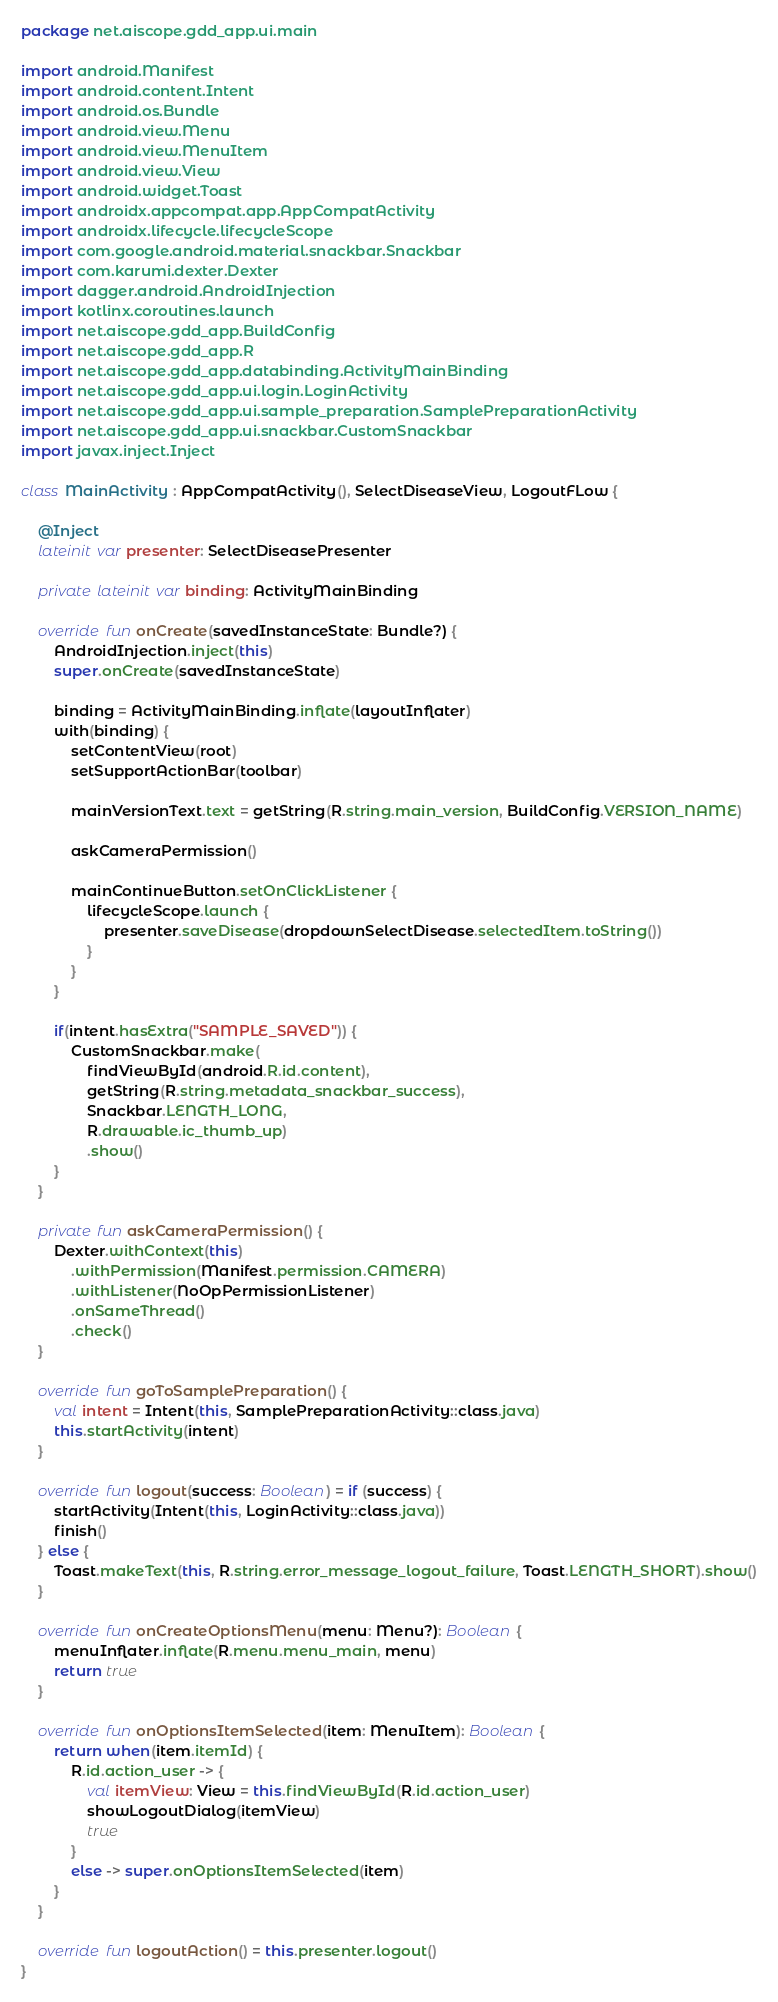<code> <loc_0><loc_0><loc_500><loc_500><_Kotlin_>package net.aiscope.gdd_app.ui.main

import android.Manifest
import android.content.Intent
import android.os.Bundle
import android.view.Menu
import android.view.MenuItem
import android.view.View
import android.widget.Toast
import androidx.appcompat.app.AppCompatActivity
import androidx.lifecycle.lifecycleScope
import com.google.android.material.snackbar.Snackbar
import com.karumi.dexter.Dexter
import dagger.android.AndroidInjection
import kotlinx.coroutines.launch
import net.aiscope.gdd_app.BuildConfig
import net.aiscope.gdd_app.R
import net.aiscope.gdd_app.databinding.ActivityMainBinding
import net.aiscope.gdd_app.ui.login.LoginActivity
import net.aiscope.gdd_app.ui.sample_preparation.SamplePreparationActivity
import net.aiscope.gdd_app.ui.snackbar.CustomSnackbar
import javax.inject.Inject

class MainActivity : AppCompatActivity(), SelectDiseaseView, LogoutFLow {

    @Inject
    lateinit var presenter: SelectDiseasePresenter

    private lateinit var binding: ActivityMainBinding

    override fun onCreate(savedInstanceState: Bundle?) {
        AndroidInjection.inject(this)
        super.onCreate(savedInstanceState)

        binding = ActivityMainBinding.inflate(layoutInflater)
        with(binding) {
            setContentView(root)
            setSupportActionBar(toolbar)

            mainVersionText.text = getString(R.string.main_version, BuildConfig.VERSION_NAME)

            askCameraPermission()

            mainContinueButton.setOnClickListener {
                lifecycleScope.launch {
                    presenter.saveDisease(dropdownSelectDisease.selectedItem.toString())
                }
            }
        }

        if(intent.hasExtra("SAMPLE_SAVED")) {
            CustomSnackbar.make(
                findViewById(android.R.id.content),
                getString(R.string.metadata_snackbar_success),
                Snackbar.LENGTH_LONG,
                R.drawable.ic_thumb_up)
                .show()
        }
    }

    private fun askCameraPermission() {
        Dexter.withContext(this)
            .withPermission(Manifest.permission.CAMERA)
            .withListener(NoOpPermissionListener)
            .onSameThread()
            .check()
    }

    override fun goToSamplePreparation() {
        val intent = Intent(this, SamplePreparationActivity::class.java)
        this.startActivity(intent)
    }

    override fun logout(success: Boolean) = if (success) {
        startActivity(Intent(this, LoginActivity::class.java))
        finish()
    } else {
        Toast.makeText(this, R.string.error_message_logout_failure, Toast.LENGTH_SHORT).show()
    }

    override fun onCreateOptionsMenu(menu: Menu?): Boolean {
        menuInflater.inflate(R.menu.menu_main, menu)
        return true
    }

    override fun onOptionsItemSelected(item: MenuItem): Boolean {
        return when(item.itemId) {
            R.id.action_user -> {
                val itemView: View = this.findViewById(R.id.action_user)
                showLogoutDialog(itemView)
                true
            }
            else -> super.onOptionsItemSelected(item)
        }
    }

    override fun logoutAction() = this.presenter.logout()
}
</code> 